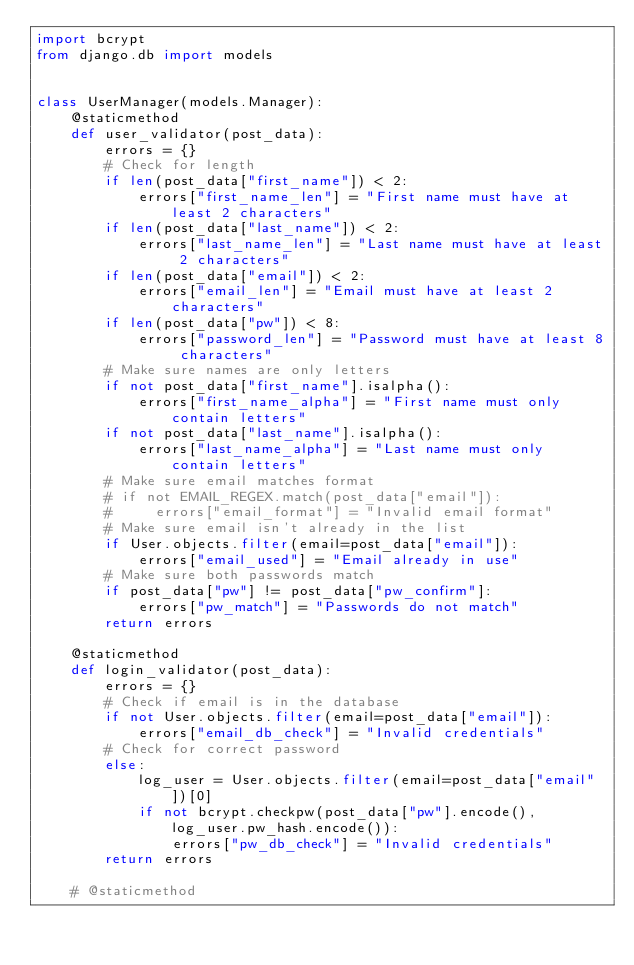<code> <loc_0><loc_0><loc_500><loc_500><_Python_>import bcrypt
from django.db import models


class UserManager(models.Manager):
    @staticmethod
    def user_validator(post_data):
        errors = {}
        # Check for length
        if len(post_data["first_name"]) < 2:
            errors["first_name_len"] = "First name must have at least 2 characters"
        if len(post_data["last_name"]) < 2:
            errors["last_name_len"] = "Last name must have at least 2 characters"
        if len(post_data["email"]) < 2:
            errors["email_len"] = "Email must have at least 2 characters"
        if len(post_data["pw"]) < 8:
            errors["password_len"] = "Password must have at least 8 characters"
        # Make sure names are only letters
        if not post_data["first_name"].isalpha():
            errors["first_name_alpha"] = "First name must only contain letters"
        if not post_data["last_name"].isalpha():
            errors["last_name_alpha"] = "Last name must only contain letters"
        # Make sure email matches format
        # if not EMAIL_REGEX.match(post_data["email"]):
        #     errors["email_format"] = "Invalid email format"
        # Make sure email isn't already in the list
        if User.objects.filter(email=post_data["email"]):
            errors["email_used"] = "Email already in use"
        # Make sure both passwords match
        if post_data["pw"] != post_data["pw_confirm"]:
            errors["pw_match"] = "Passwords do not match"
        return errors

    @staticmethod
    def login_validator(post_data):
        errors = {}
        # Check if email is in the database
        if not User.objects.filter(email=post_data["email"]):
            errors["email_db_check"] = "Invalid credentials"
        # Check for correct password
        else:
            log_user = User.objects.filter(email=post_data["email"])[0]
            if not bcrypt.checkpw(post_data["pw"].encode(), log_user.pw_hash.encode()):
                errors["pw_db_check"] = "Invalid credentials"
        return errors

    # @staticmethod</code> 